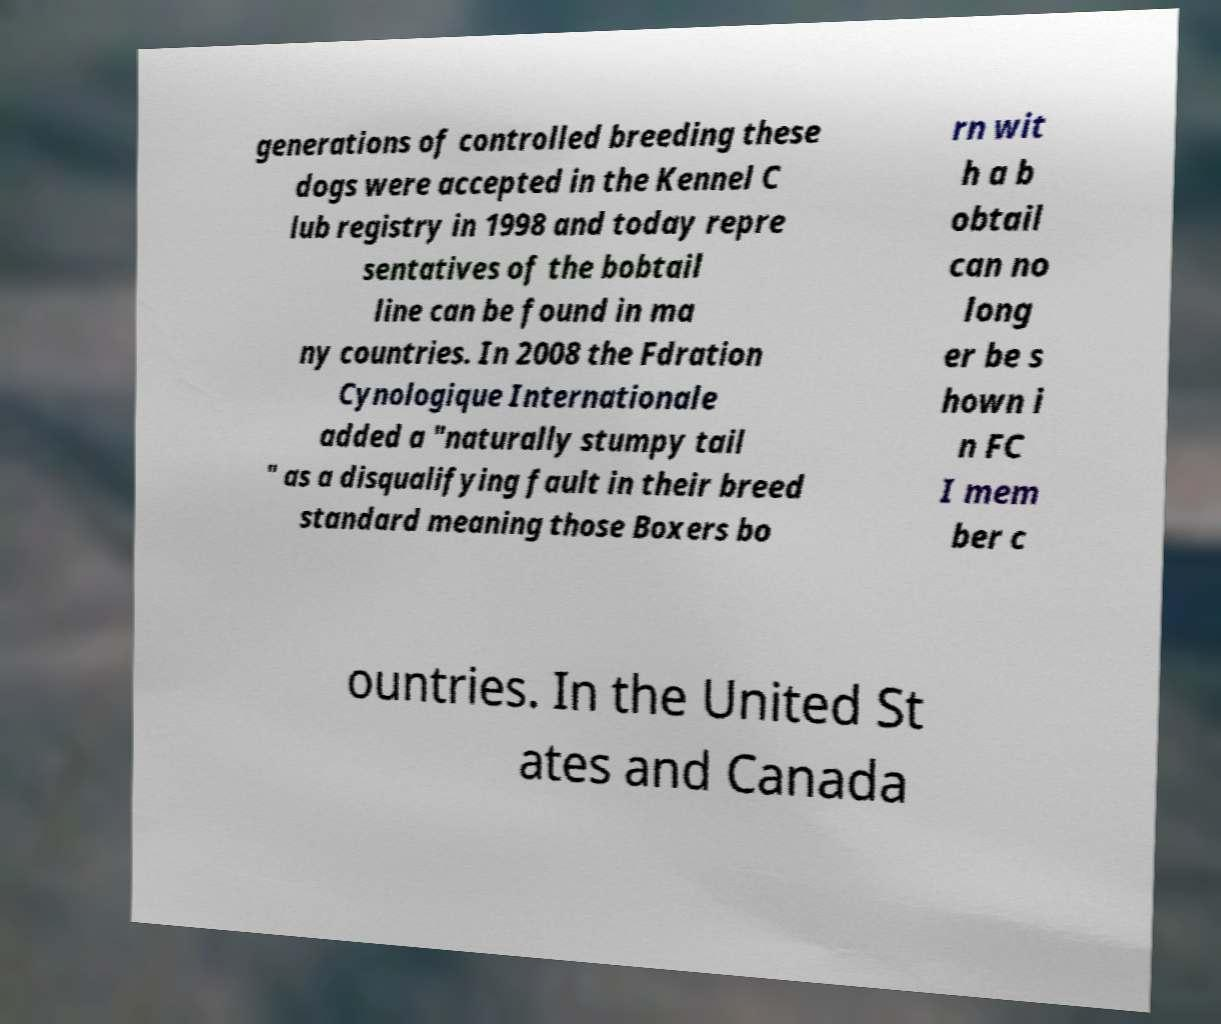Can you read and provide the text displayed in the image?This photo seems to have some interesting text. Can you extract and type it out for me? generations of controlled breeding these dogs were accepted in the Kennel C lub registry in 1998 and today repre sentatives of the bobtail line can be found in ma ny countries. In 2008 the Fdration Cynologique Internationale added a "naturally stumpy tail " as a disqualifying fault in their breed standard meaning those Boxers bo rn wit h a b obtail can no long er be s hown i n FC I mem ber c ountries. In the United St ates and Canada 